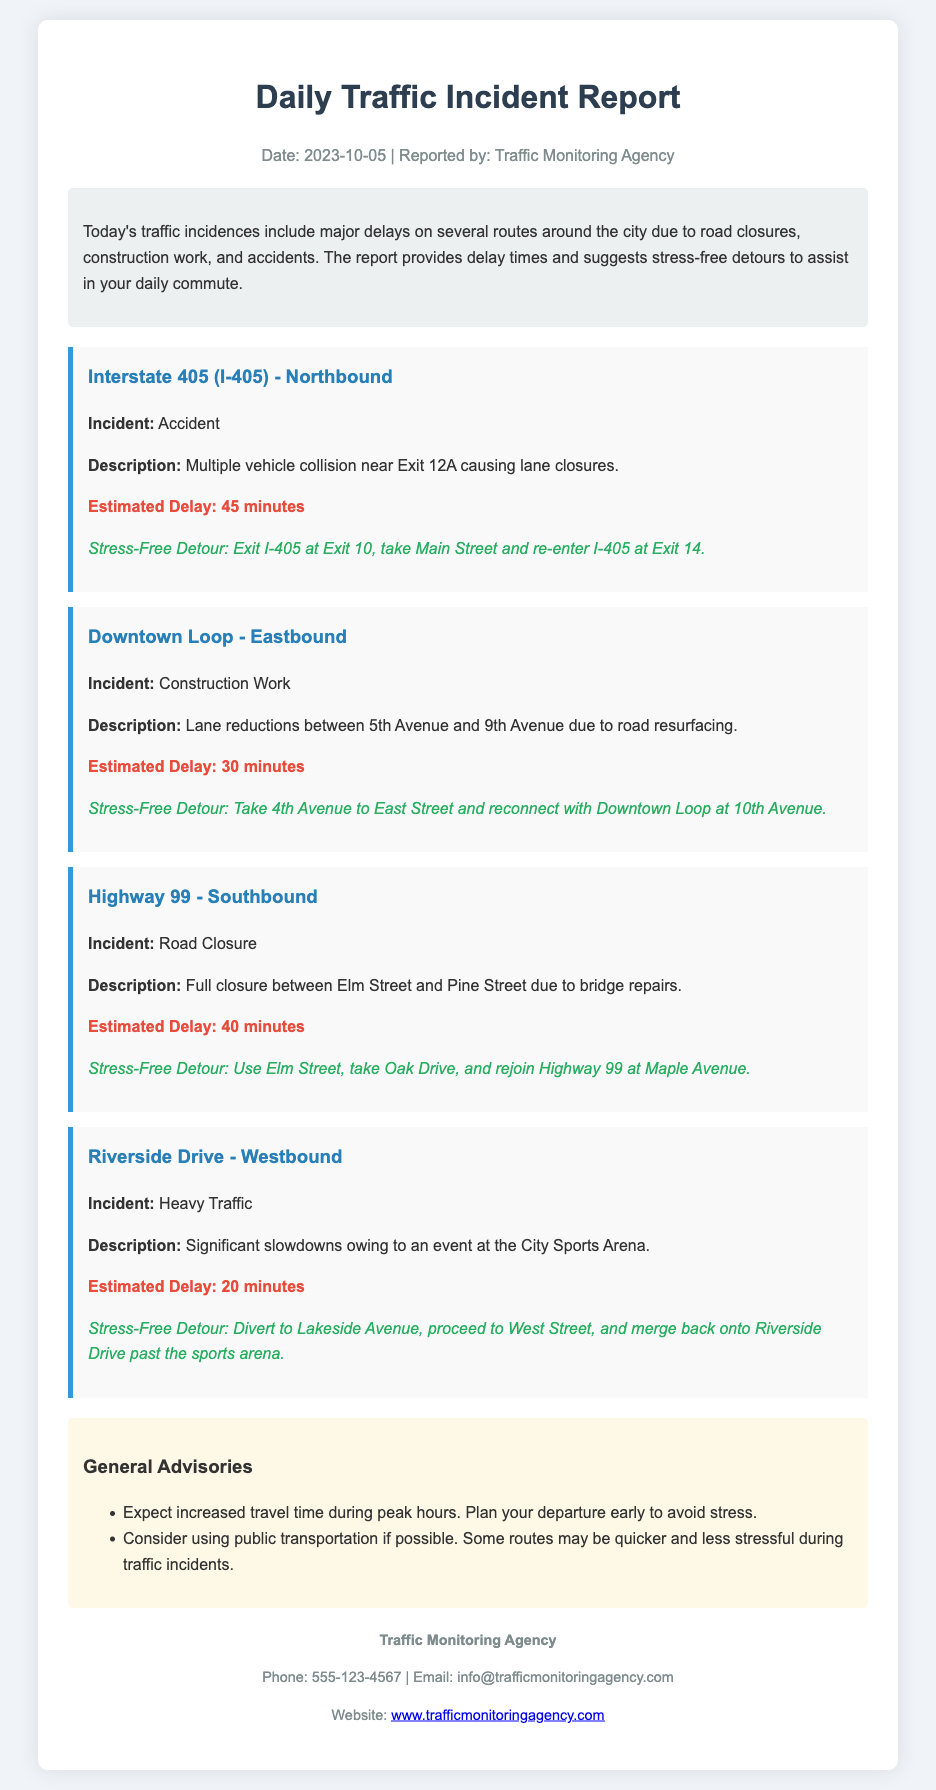What date is the report from? The report provides the date at the top, which is the publication date of the traffic incident report.
Answer: 2023-10-05 How many incidents are reported? The document lists four specific incidents under the "incidents" section.
Answer: 4 What is the estimated delay for Interstate 405 (I-405)? The estimated delay for this incident is provided in the description of the incident itself.
Answer: 45 minutes What kind of incident is reported on Riverside Drive? The type of incident is mentioned in the title and description of the incident section for Riverside Drive.
Answer: Heavy Traffic What is the stress-free detour for Highway 99? The stress-free detour is outlined in the description of the incident for Highway 99, providing an alternative route.
Answer: Use Elm Street, take Oak Drive, and rejoin Highway 99 at Maple Avenue What should you expect during peak hours according to the general advisories? The advisories section notes general expectations for travel time during peak hours based on the traffic situation.
Answer: Increased travel time What is the contact email for the Traffic Monitoring Agency? The email address for contacting the Traffic Monitoring Agency is specified at the bottom of the document.
Answer: info@trafficmonitoringagency.com What type of report is this document presenting? The type of report is specified in the title of the document.
Answer: Traffic Incident Report 